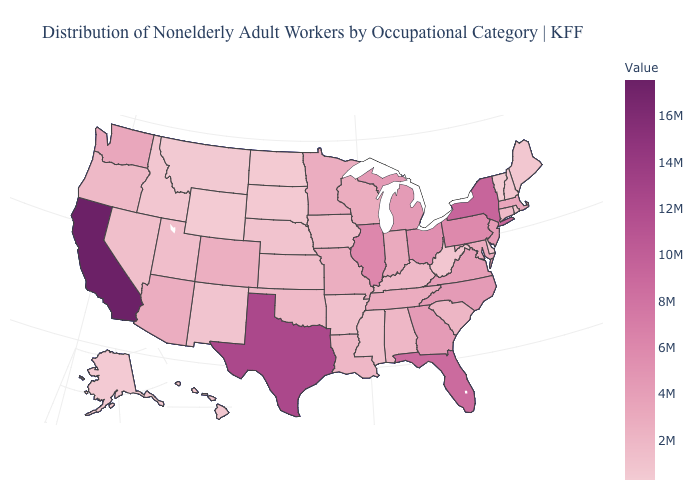Which states hav the highest value in the West?
Give a very brief answer. California. Does Wyoming have the lowest value in the USA?
Short answer required. Yes. Which states have the lowest value in the USA?
Give a very brief answer. Wyoming. Does Wyoming have the lowest value in the USA?
Concise answer only. Yes. Is the legend a continuous bar?
Concise answer only. Yes. 